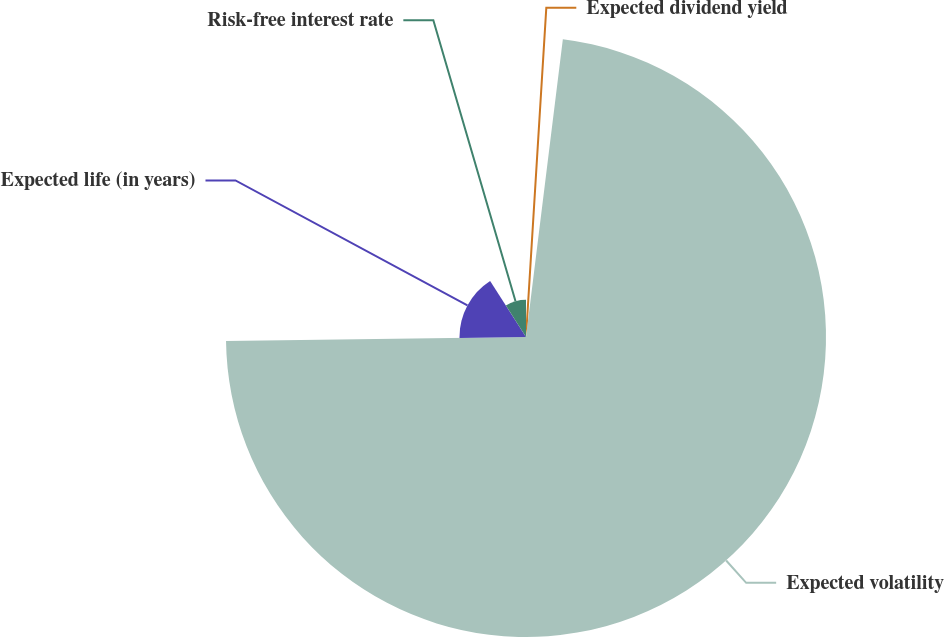Convert chart. <chart><loc_0><loc_0><loc_500><loc_500><pie_chart><fcel>Expected dividend yield<fcel>Expected volatility<fcel>Expected life (in years)<fcel>Risk-free interest rate<nl><fcel>1.96%<fcel>72.83%<fcel>16.15%<fcel>9.06%<nl></chart> 